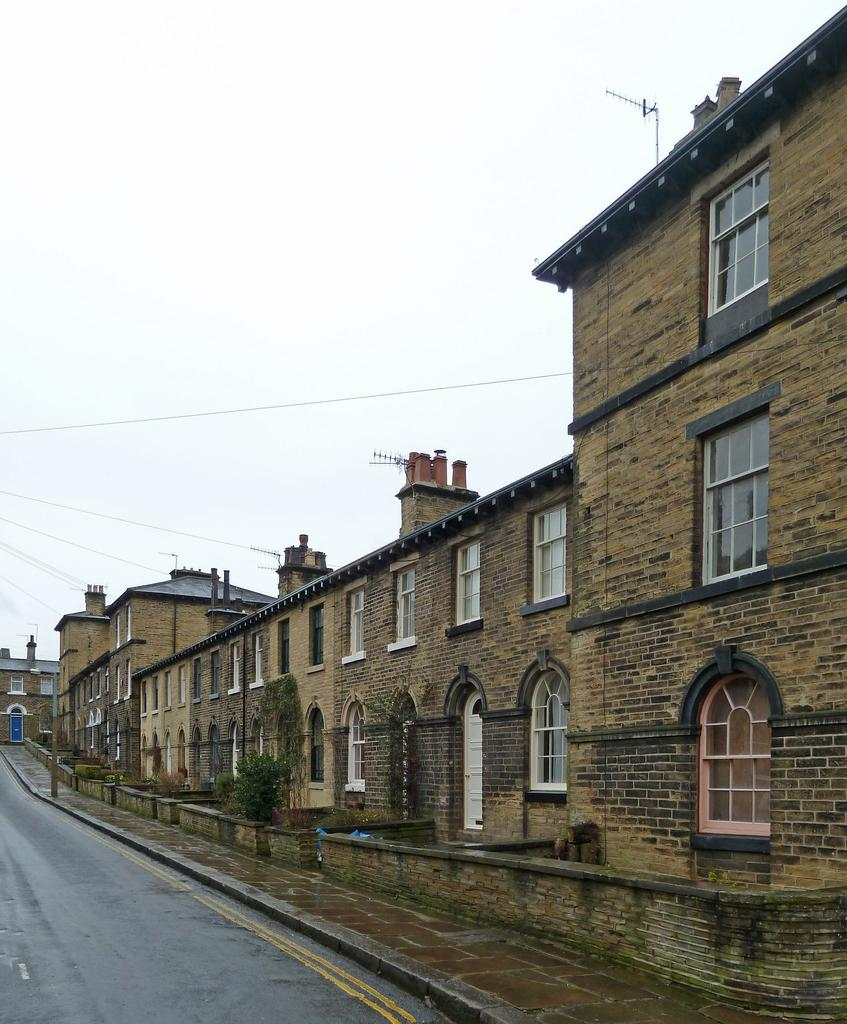What type of structure is present in the image? There is a building in the image. What features can be observed on the building? The building has windows and doors. What is located in the center of the image? There is a tree in the center of the image. What can be seen in the background of the image? There are cables and the sky visible in the background of the image. How many chickens are sitting on the notebook in the image? There are no chickens or notebooks present in the image. What type of flowers can be seen growing near the tree in the image? There are no flowers visible in the image; only the tree and the building are present. 